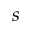<formula> <loc_0><loc_0><loc_500><loc_500>s</formula> 